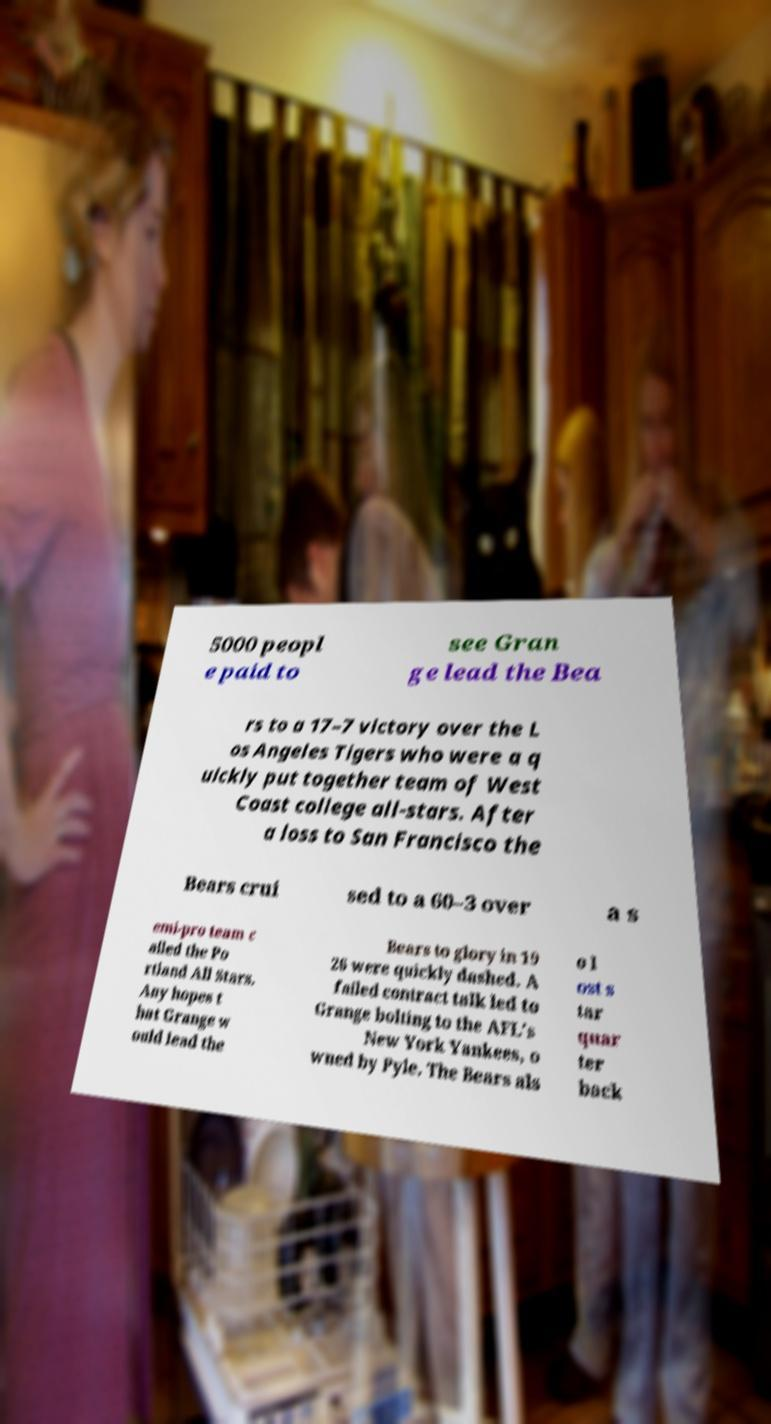There's text embedded in this image that I need extracted. Can you transcribe it verbatim? 5000 peopl e paid to see Gran ge lead the Bea rs to a 17–7 victory over the L os Angeles Tigers who were a q uickly put together team of West Coast college all-stars. After a loss to San Francisco the Bears crui sed to a 60–3 over a s emi-pro team c alled the Po rtland All Stars. Any hopes t hat Grange w ould lead the Bears to glory in 19 26 were quickly dashed. A failed contract talk led to Grange bolting to the AFL's New York Yankees, o wned by Pyle. The Bears als o l ost s tar quar ter back 